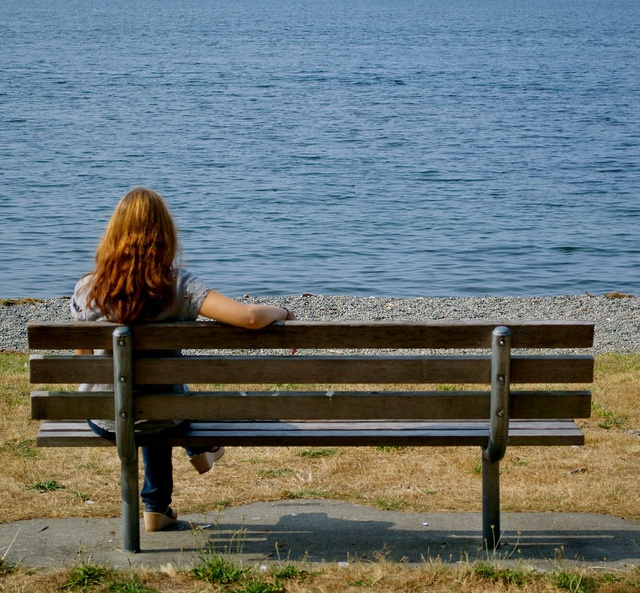Describe the objects in this image and their specific colors. I can see bench in gray, black, darkgray, and tan tones and people in gray, black, maroon, brown, and darkgray tones in this image. 